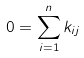<formula> <loc_0><loc_0><loc_500><loc_500>0 = \sum _ { i = 1 } ^ { n } k _ { i j }</formula> 